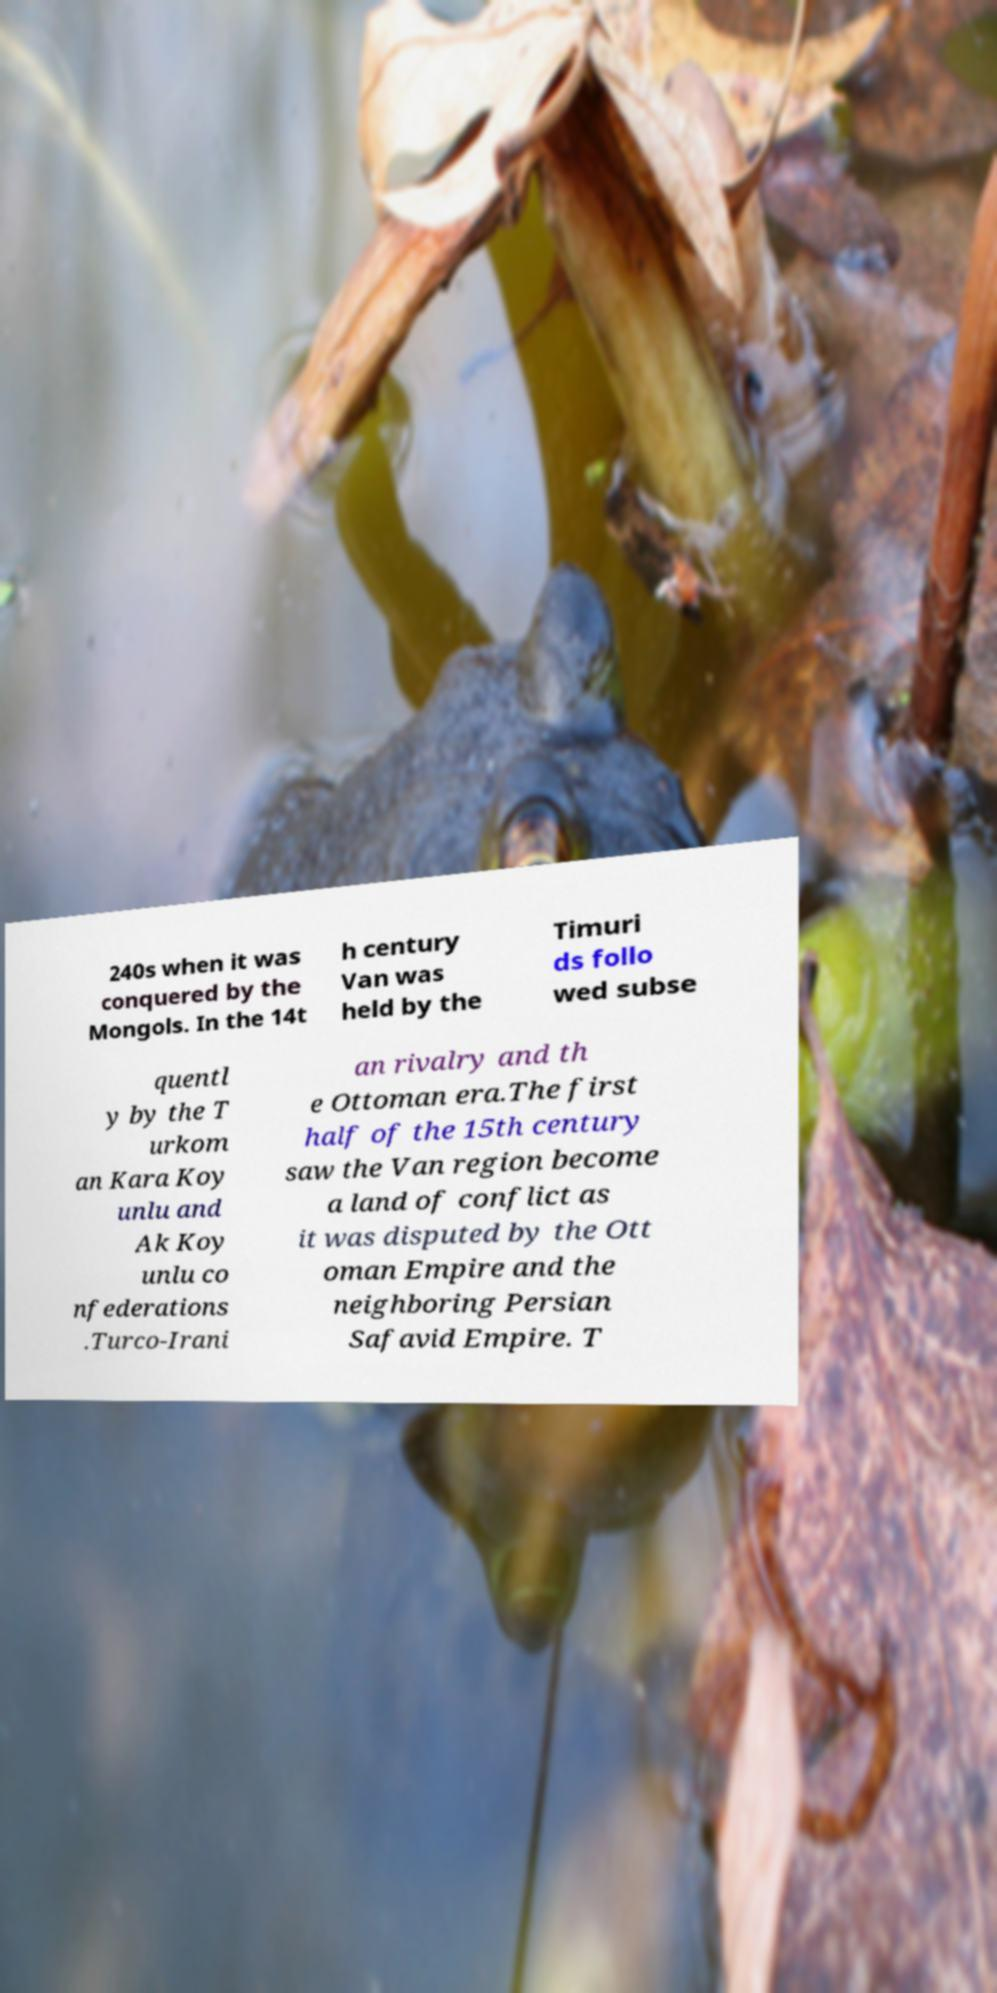For documentation purposes, I need the text within this image transcribed. Could you provide that? 240s when it was conquered by the Mongols. In the 14t h century Van was held by the Timuri ds follo wed subse quentl y by the T urkom an Kara Koy unlu and Ak Koy unlu co nfederations .Turco-Irani an rivalry and th e Ottoman era.The first half of the 15th century saw the Van region become a land of conflict as it was disputed by the Ott oman Empire and the neighboring Persian Safavid Empire. T 